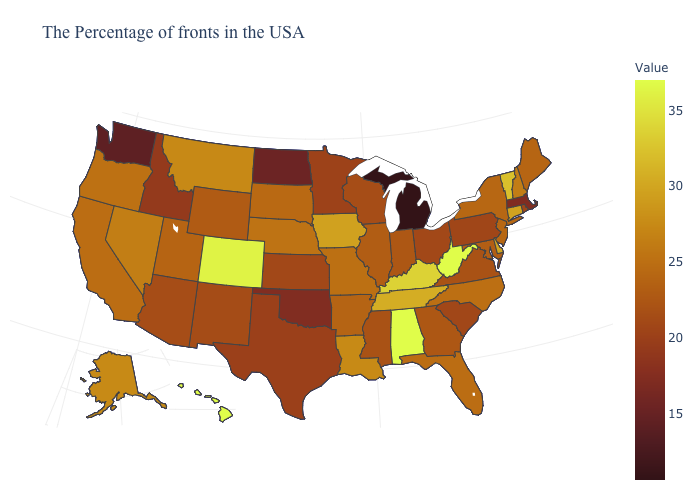Is the legend a continuous bar?
Give a very brief answer. Yes. 